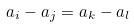<formula> <loc_0><loc_0><loc_500><loc_500>a _ { i } - a _ { j } = a _ { k } - a _ { l }</formula> 